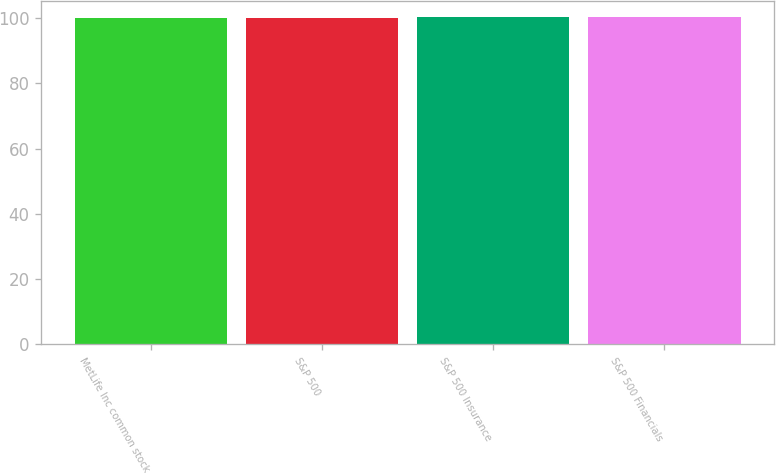Convert chart to OTSL. <chart><loc_0><loc_0><loc_500><loc_500><bar_chart><fcel>MetLife Inc common stock<fcel>S&P 500<fcel>S&P 500 Insurance<fcel>S&P 500 Financials<nl><fcel>100<fcel>100.1<fcel>100.2<fcel>100.3<nl></chart> 